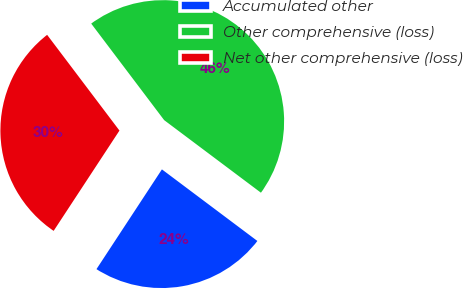Convert chart to OTSL. <chart><loc_0><loc_0><loc_500><loc_500><pie_chart><fcel>Accumulated other<fcel>Other comprehensive (loss)<fcel>Net other comprehensive (loss)<nl><fcel>24.0%<fcel>45.54%<fcel>30.46%<nl></chart> 